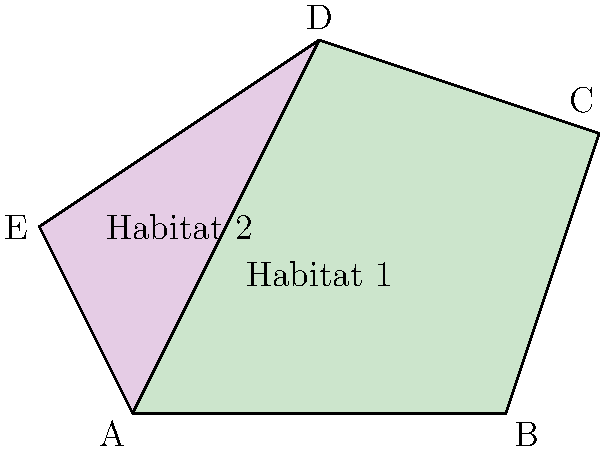Two endangered plant species habitats are represented by irregular polygons on a map. Habitat 1 is defined by points ABCD, and Habitat 2 is defined by points ADE. If each unit on the map represents 100 meters, what is the total area of both habitats combined in square meters? To solve this problem, we need to calculate the areas of both polygons and add them together. We'll use the vector cross product method to find the areas.

1. For Habitat 1 (ABCD):
   Let $\vec{v_1} = \overrightarrow{AB} = (4,0)$
   Let $\vec{v_2} = \overrightarrow{AC} = (5,3)$
   Let $\vec{v_3} = \overrightarrow{AD} = (2,4)$
   
   Area = $\frac{1}{2}|(\vec{v_1} \times \vec{v_2}) + (\vec{v_2} \times \vec{v_3}) + (\vec{v_3} \times \vec{v_1})|$
        = $\frac{1}{2}|(0 + 15) + (14 + 10) + (-16 - 0)|$
        = $\frac{1}{2}|23|$ = 11.5 square units

2. For Habitat 2 (ADE):
   Let $\vec{w_1} = \overrightarrow{AD} = (2,4)$
   Let $\vec{w_2} = \overrightarrow{AE} = (-1,2)$
   
   Area = $\frac{1}{2}|\vec{w_1} \times \vec{w_2}|$
        = $\frac{1}{2}|(2)(2) - (4)(-1)|$
        = $\frac{1}{2}|4 + 4|$ = 4 square units

3. Total area = Area of Habitat 1 + Area of Habitat 2
               = 11.5 + 4 = 15.5 square units

4. Convert to square meters:
   Each unit represents 100 meters, so each square unit is 10,000 square meters.
   Total area in square meters = 15.5 * 10,000 = 155,000 square meters
Answer: 155,000 square meters 